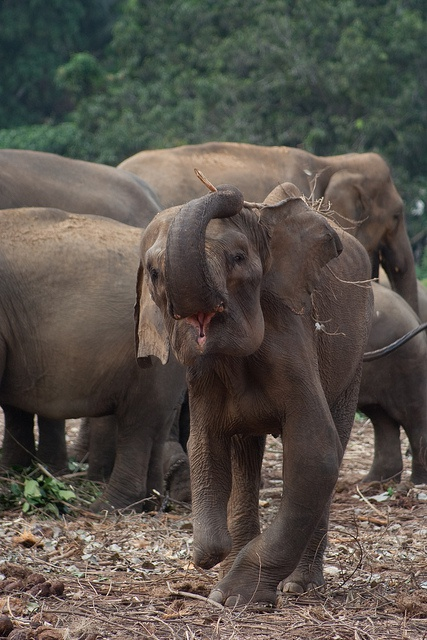Describe the objects in this image and their specific colors. I can see elephant in black and gray tones, elephant in black and gray tones, elephant in black, gray, and tan tones, elephant in black, gray, and darkgray tones, and elephant in black, gray, and darkgray tones in this image. 